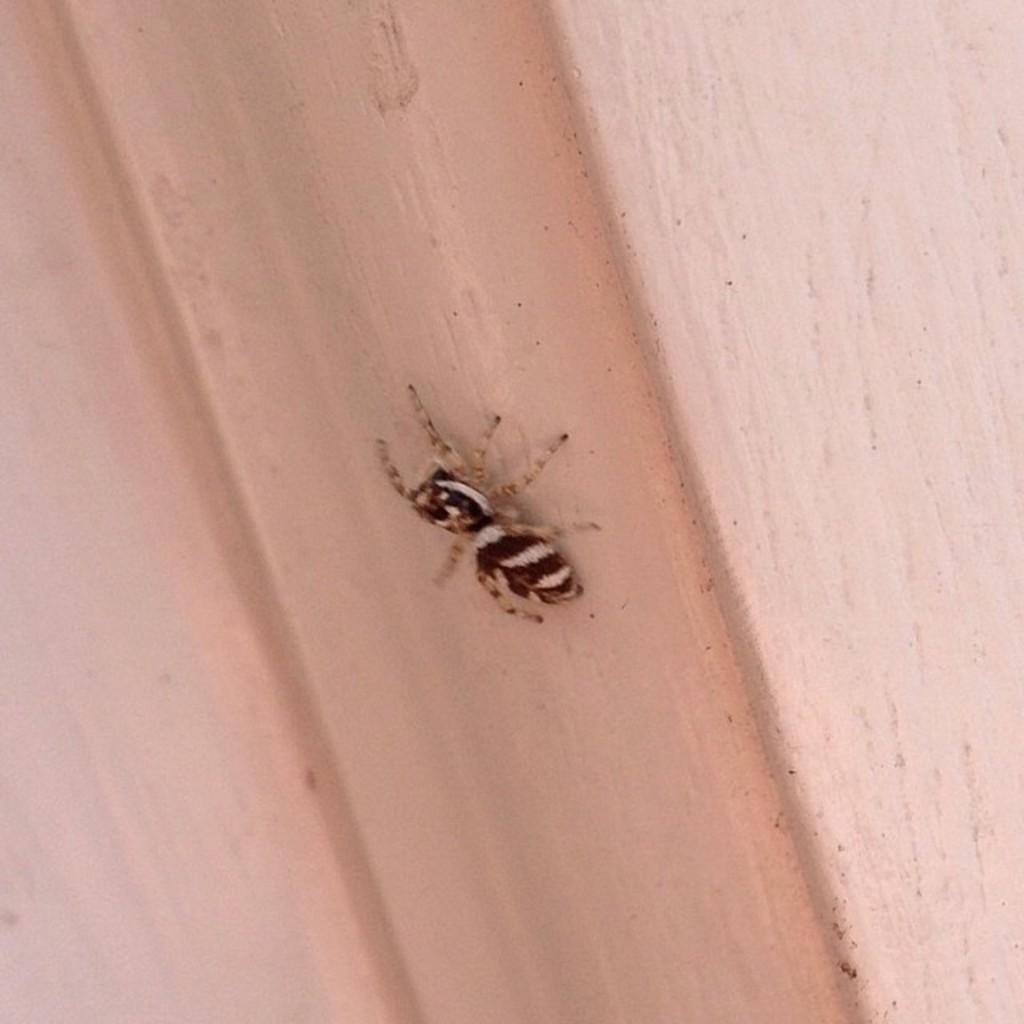Can you describe this image briefly? In the center of the image we can see a spider on the wall. 